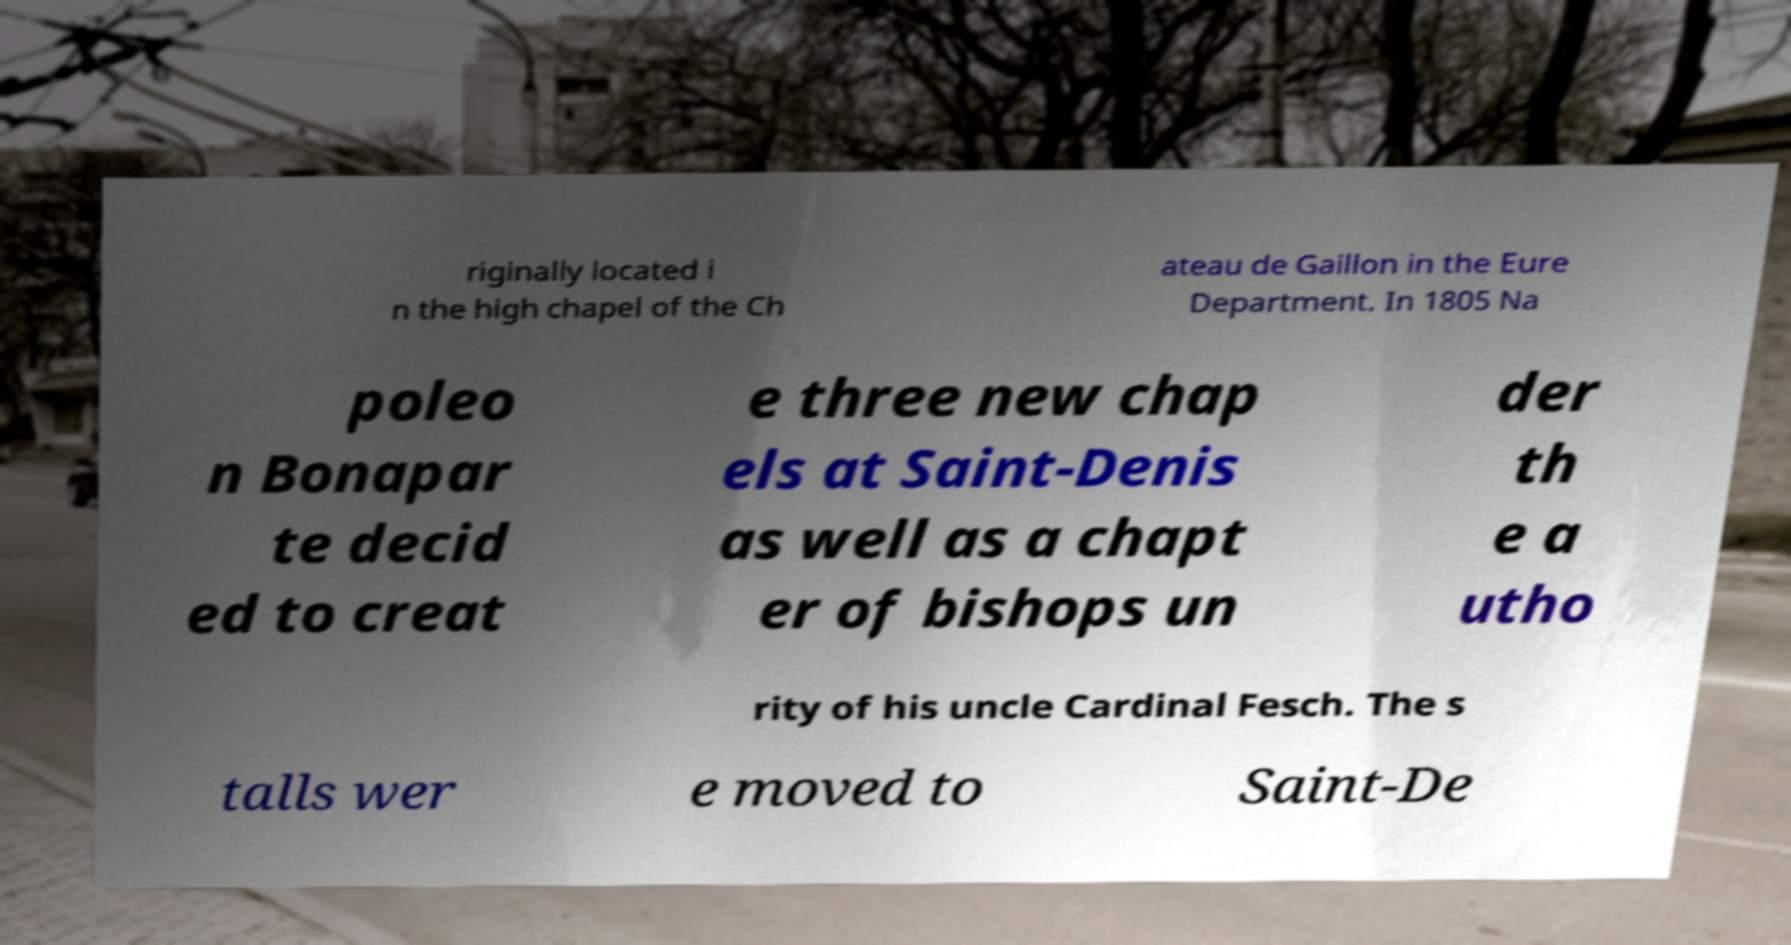What messages or text are displayed in this image? I need them in a readable, typed format. riginally located i n the high chapel of the Ch ateau de Gaillon in the Eure Department. In 1805 Na poleo n Bonapar te decid ed to creat e three new chap els at Saint-Denis as well as a chapt er of bishops un der th e a utho rity of his uncle Cardinal Fesch. The s talls wer e moved to Saint-De 